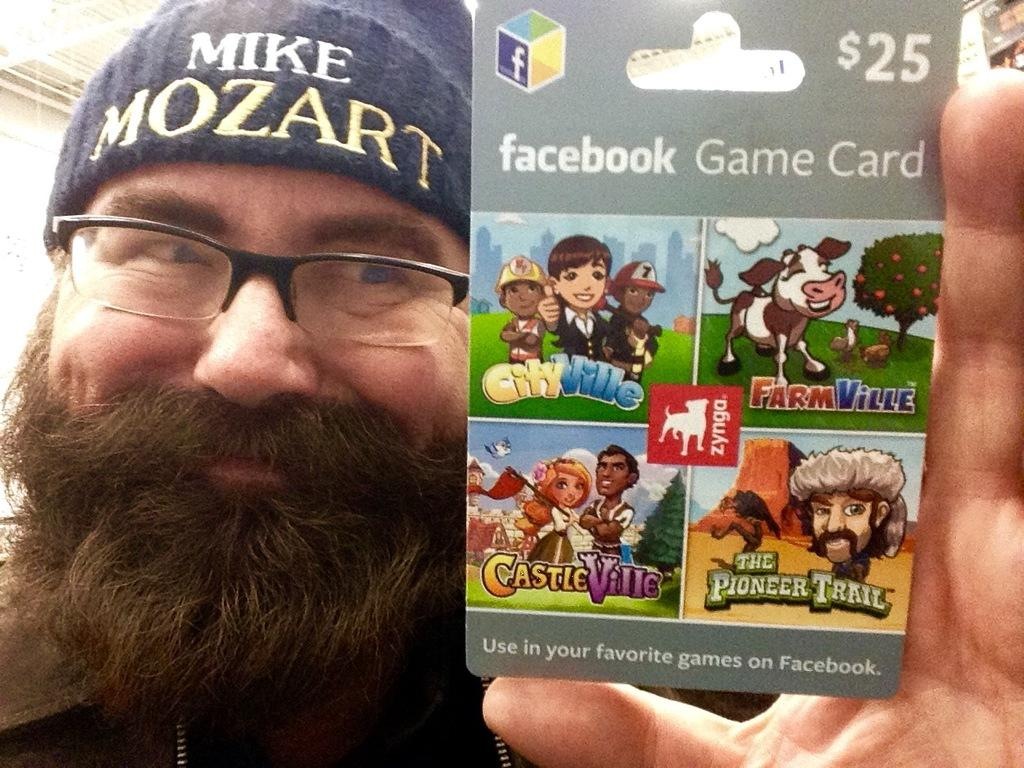What is the man on the left side of the image doing? The man is holding a poster. What can be seen on the man's head? The man is wearing a cap. What is the man wearing on his face? The man is wearing spectacles. What is depicted on the poster the man is holding? The poster contains images of animals, people, trees, and grass, as well as text. What type of iron is being used to level the ground in the image? There is no iron or leveling activity present in the image. What is the scarecrow doing in the image? There is no scarecrow present in the image. 